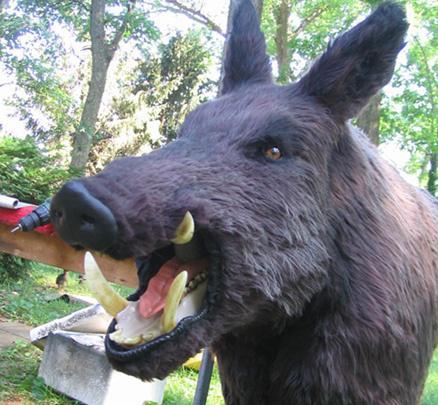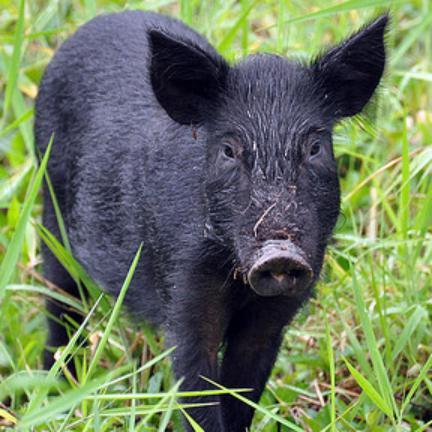The first image is the image on the left, the second image is the image on the right. Considering the images on both sides, is "An animals is walking with its babies." valid? Answer yes or no. No. 